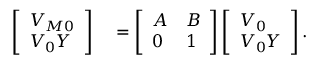Convert formula to latex. <formula><loc_0><loc_0><loc_500><loc_500>\begin{array} { r l } { \left [ \begin{array} { l } { V _ { M 0 } } \\ { V _ { 0 } Y } \end{array} \right ] } & = \left [ \begin{array} { l l } { A } & { B } \\ { 0 } & { 1 } \end{array} \right ] \left [ \begin{array} { l } { V _ { 0 } } \\ { V _ { 0 } Y } \end{array} \right ] . } \end{array}</formula> 